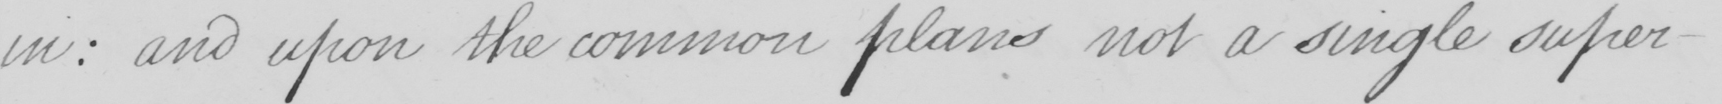Please provide the text content of this handwritten line. in :  and upon the common plans not a single super- 